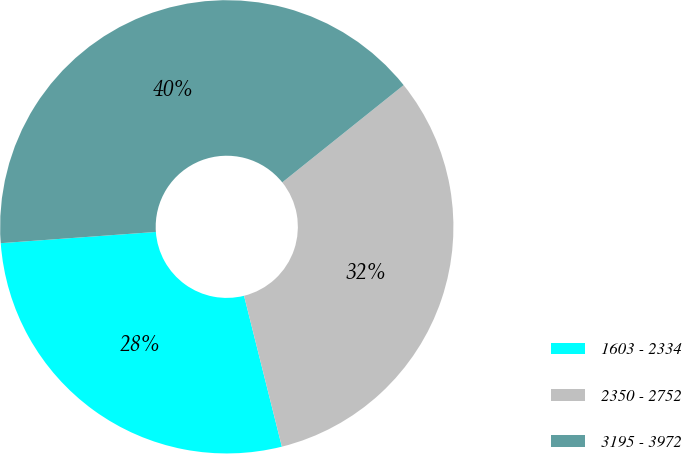Convert chart to OTSL. <chart><loc_0><loc_0><loc_500><loc_500><pie_chart><fcel>1603 - 2334<fcel>2350 - 2752<fcel>3195 - 3972<nl><fcel>27.76%<fcel>31.84%<fcel>40.4%<nl></chart> 